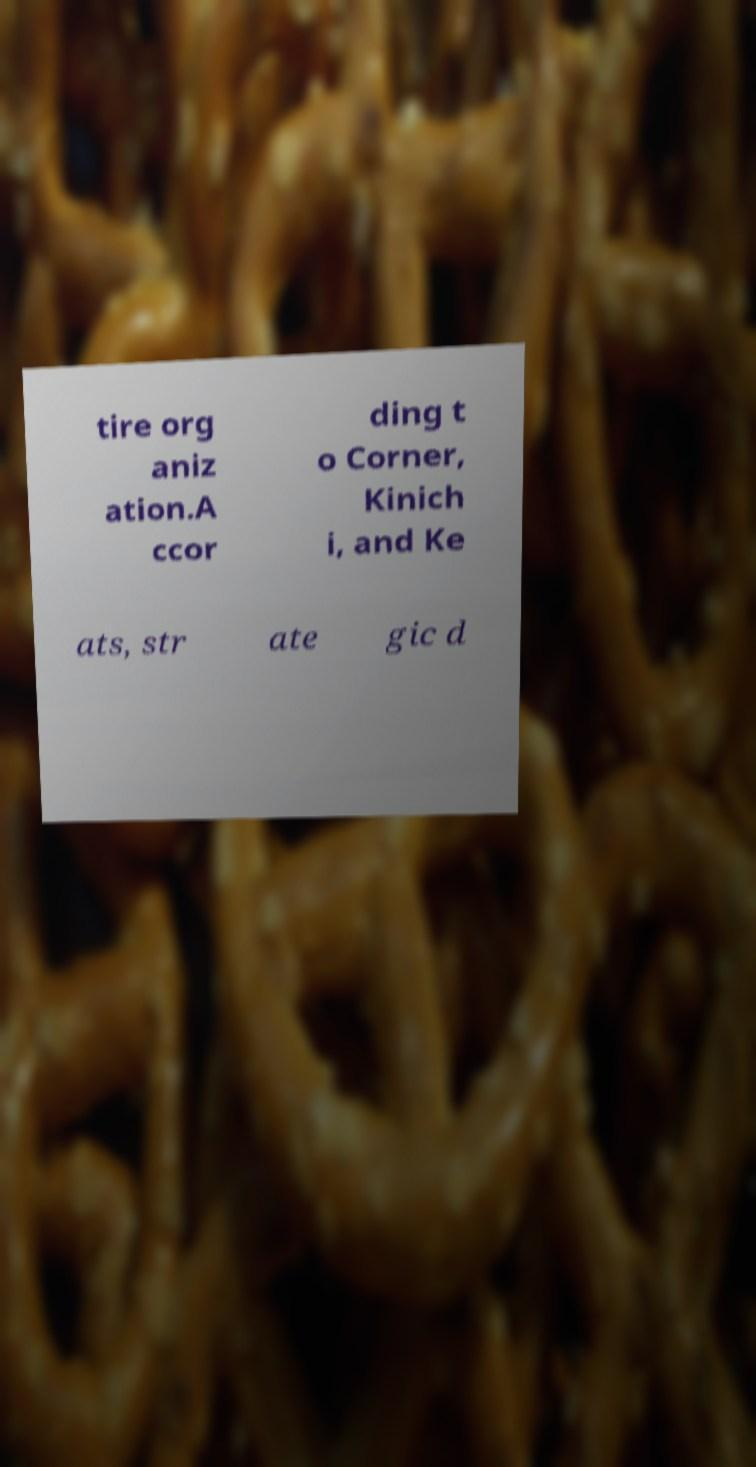Can you read and provide the text displayed in the image?This photo seems to have some interesting text. Can you extract and type it out for me? tire org aniz ation.A ccor ding t o Corner, Kinich i, and Ke ats, str ate gic d 